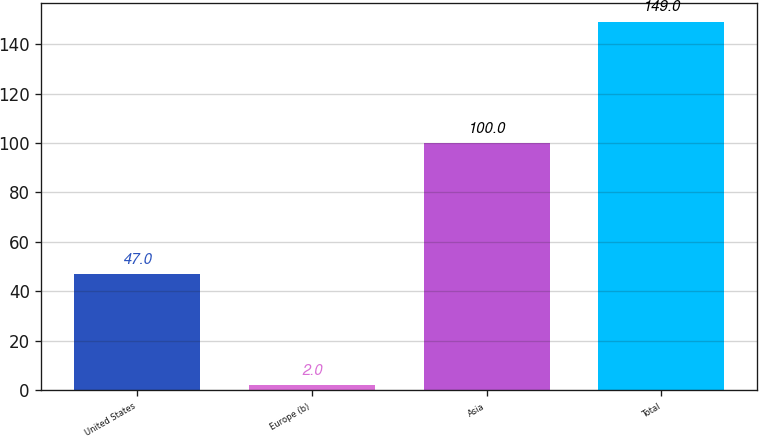<chart> <loc_0><loc_0><loc_500><loc_500><bar_chart><fcel>United States<fcel>Europe (b)<fcel>Asia<fcel>Total<nl><fcel>47<fcel>2<fcel>100<fcel>149<nl></chart> 